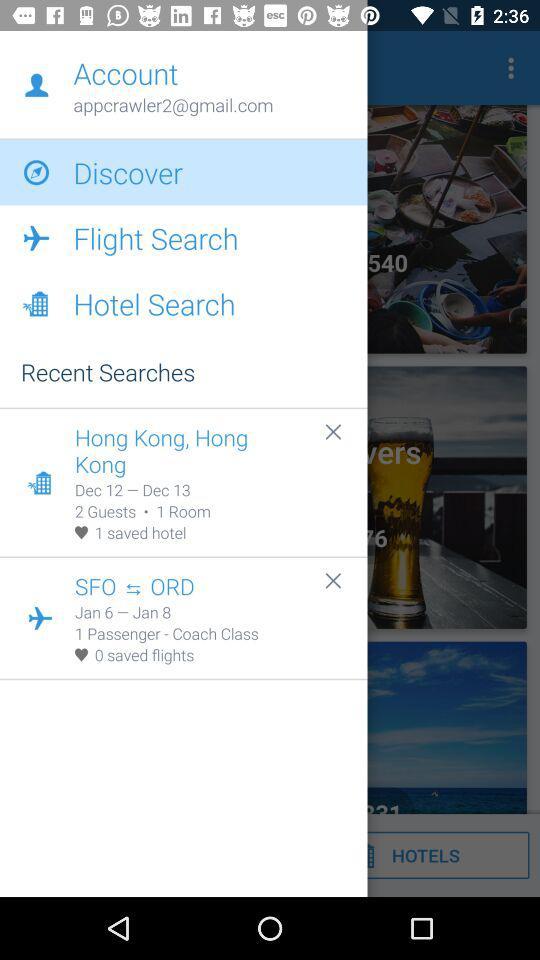How many rooms are selected for the Hong Kong location? The selected room for the Hong Kong location is 1. 